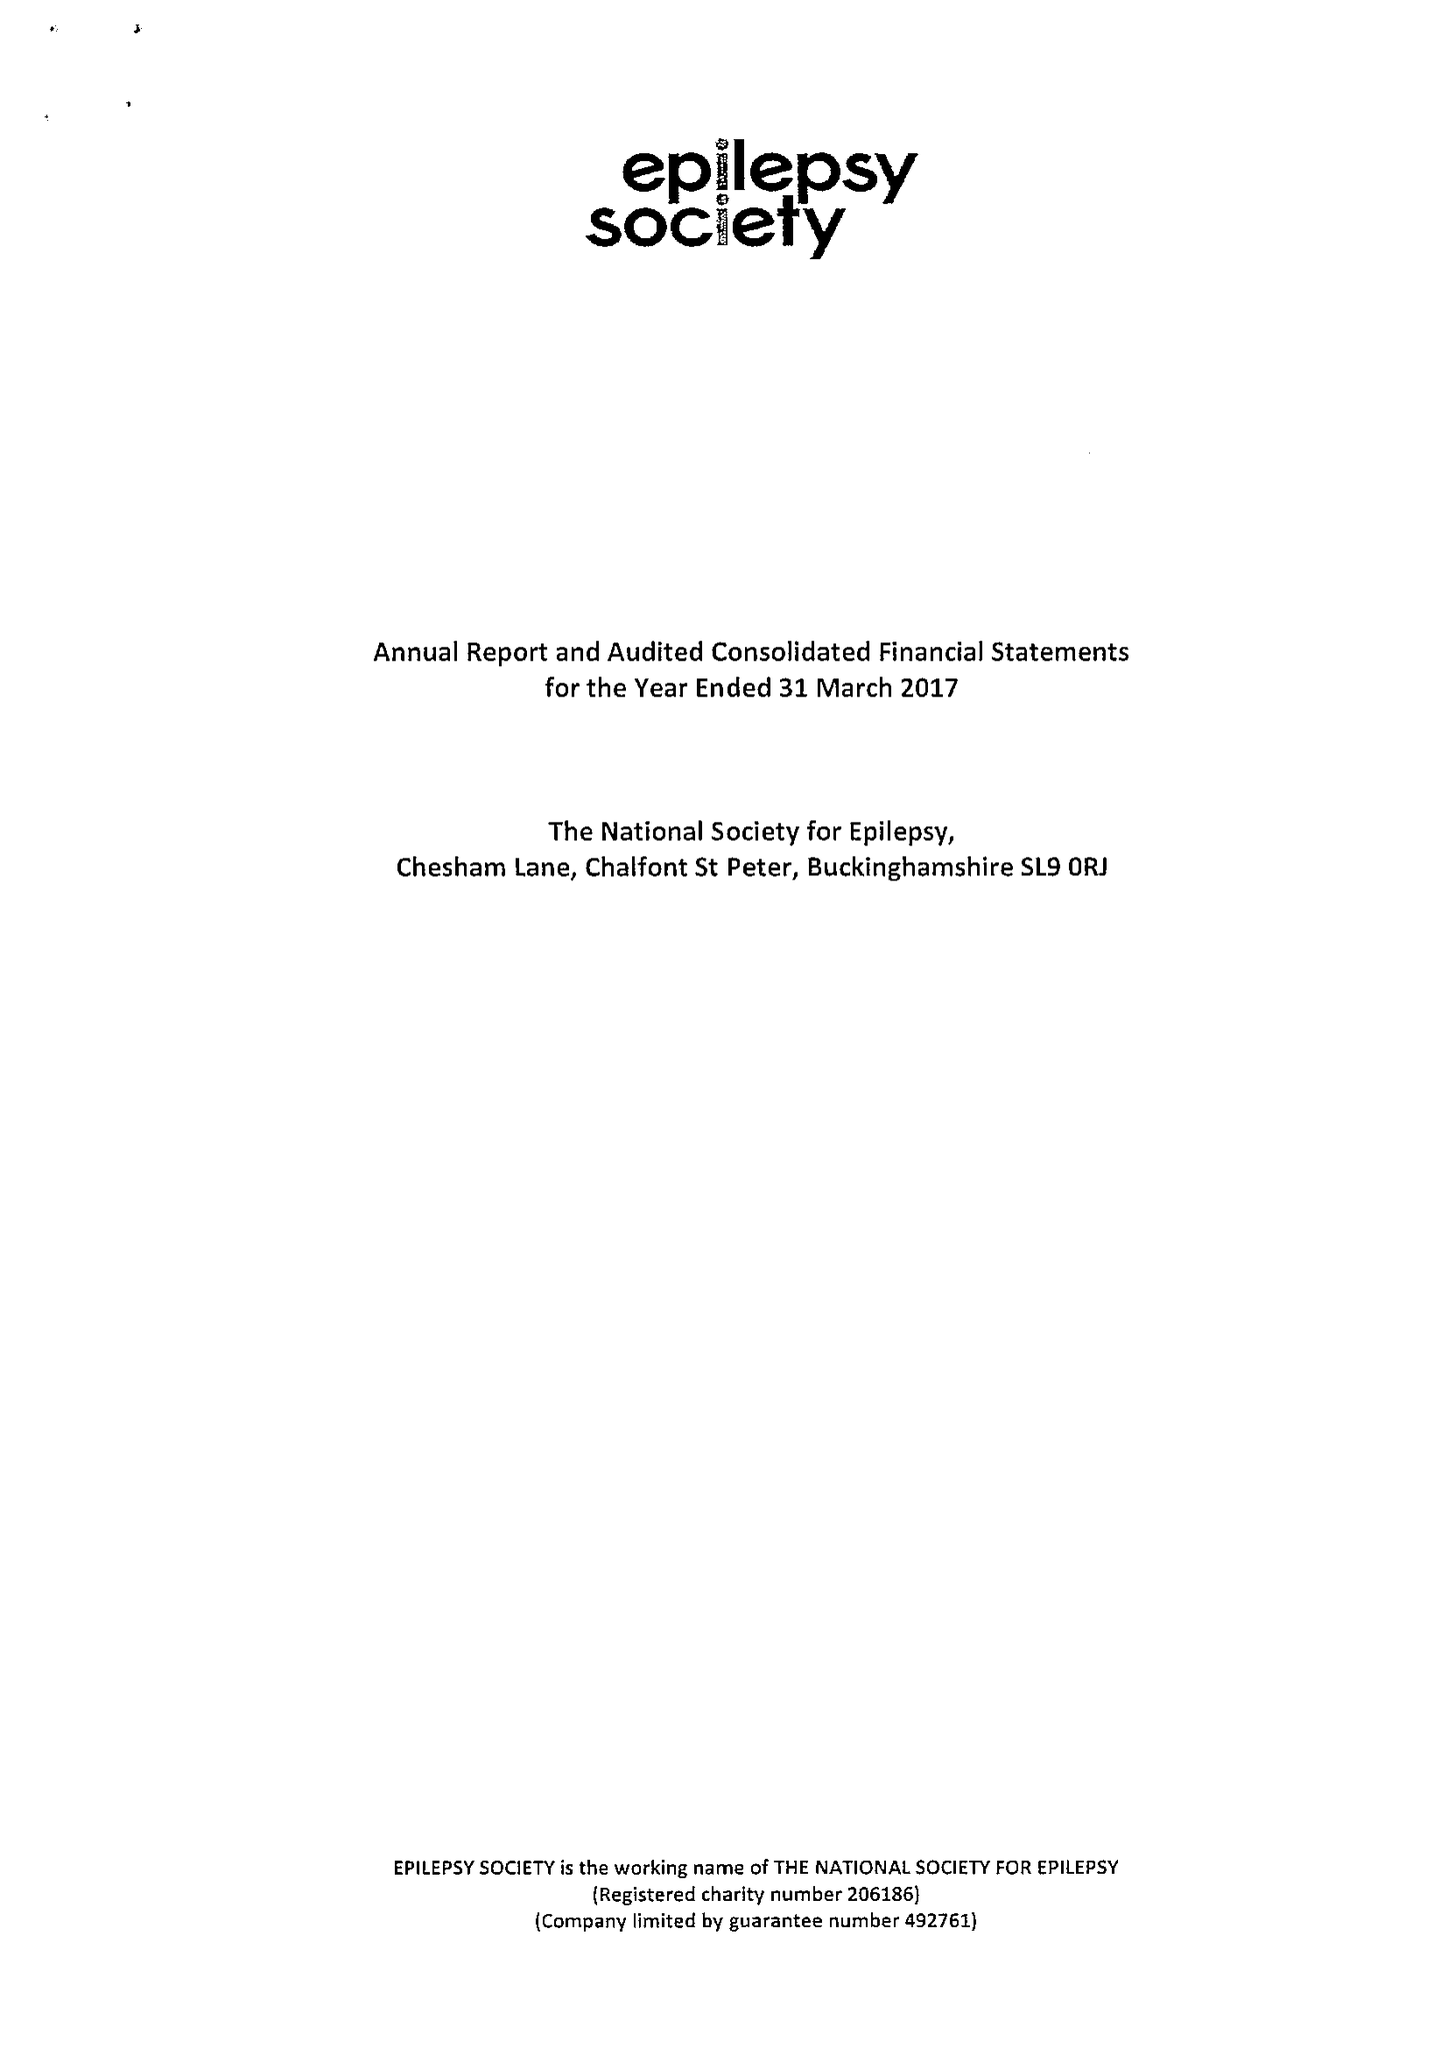What is the value for the charity_name?
Answer the question using a single word or phrase. Epilepsy Society 